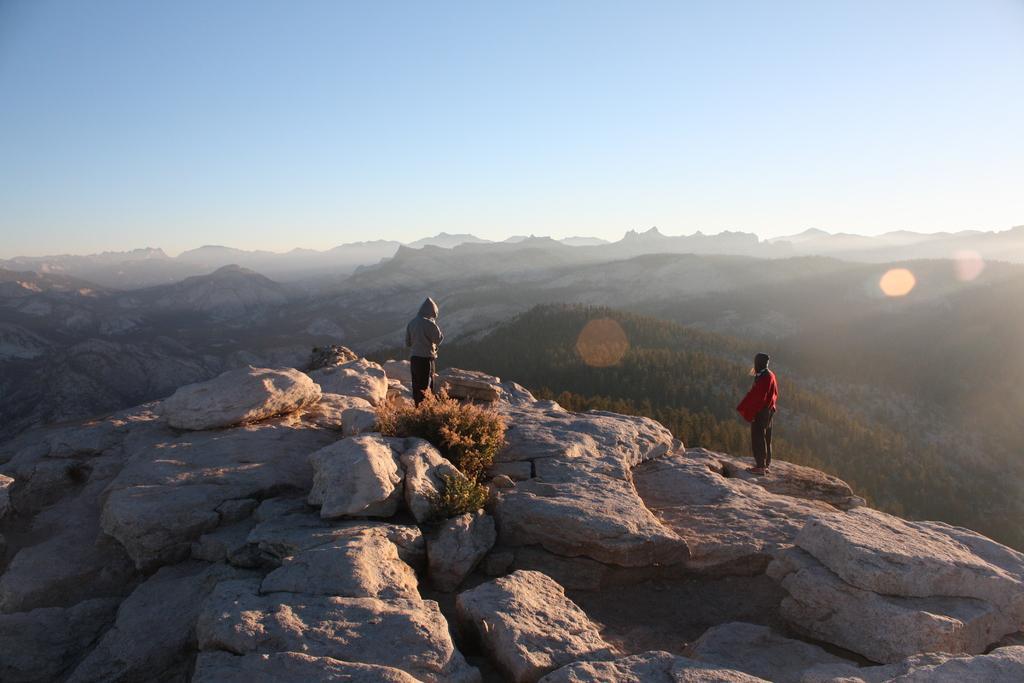Describe this image in one or two sentences. This image consists of two persons standing on the mountain. At the bottom, there are rocks. In the background, there are mountains. At the top, there is a sky. 